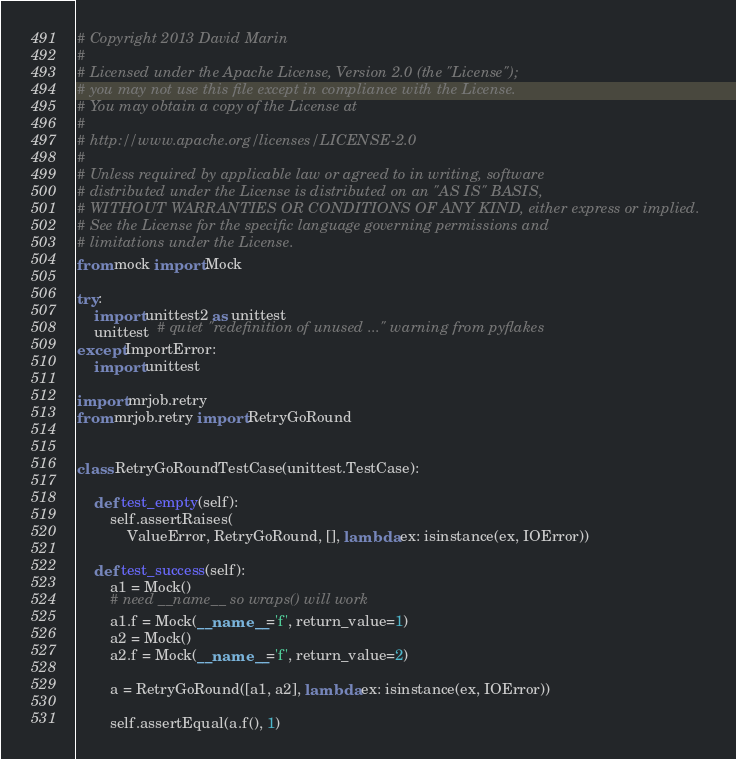Convert code to text. <code><loc_0><loc_0><loc_500><loc_500><_Python_># Copyright 2013 David Marin
#
# Licensed under the Apache License, Version 2.0 (the "License");
# you may not use this file except in compliance with the License.
# You may obtain a copy of the License at
#
# http://www.apache.org/licenses/LICENSE-2.0
#
# Unless required by applicable law or agreed to in writing, software
# distributed under the License is distributed on an "AS IS" BASIS,
# WITHOUT WARRANTIES OR CONDITIONS OF ANY KIND, either express or implied.
# See the License for the specific language governing permissions and
# limitations under the License.
from mock import Mock

try:
    import unittest2 as unittest
    unittest  # quiet "redefinition of unused ..." warning from pyflakes
except ImportError:
    import unittest

import mrjob.retry
from mrjob.retry import RetryGoRound


class RetryGoRoundTestCase(unittest.TestCase):

    def test_empty(self):
        self.assertRaises(
            ValueError, RetryGoRound, [], lambda ex: isinstance(ex, IOError))

    def test_success(self):
        a1 = Mock()
        # need __name__ so wraps() will work
        a1.f = Mock(__name__='f', return_value=1)
        a2 = Mock()
        a2.f = Mock(__name__='f', return_value=2)

        a = RetryGoRound([a1, a2], lambda ex: isinstance(ex, IOError))

        self.assertEqual(a.f(), 1)</code> 